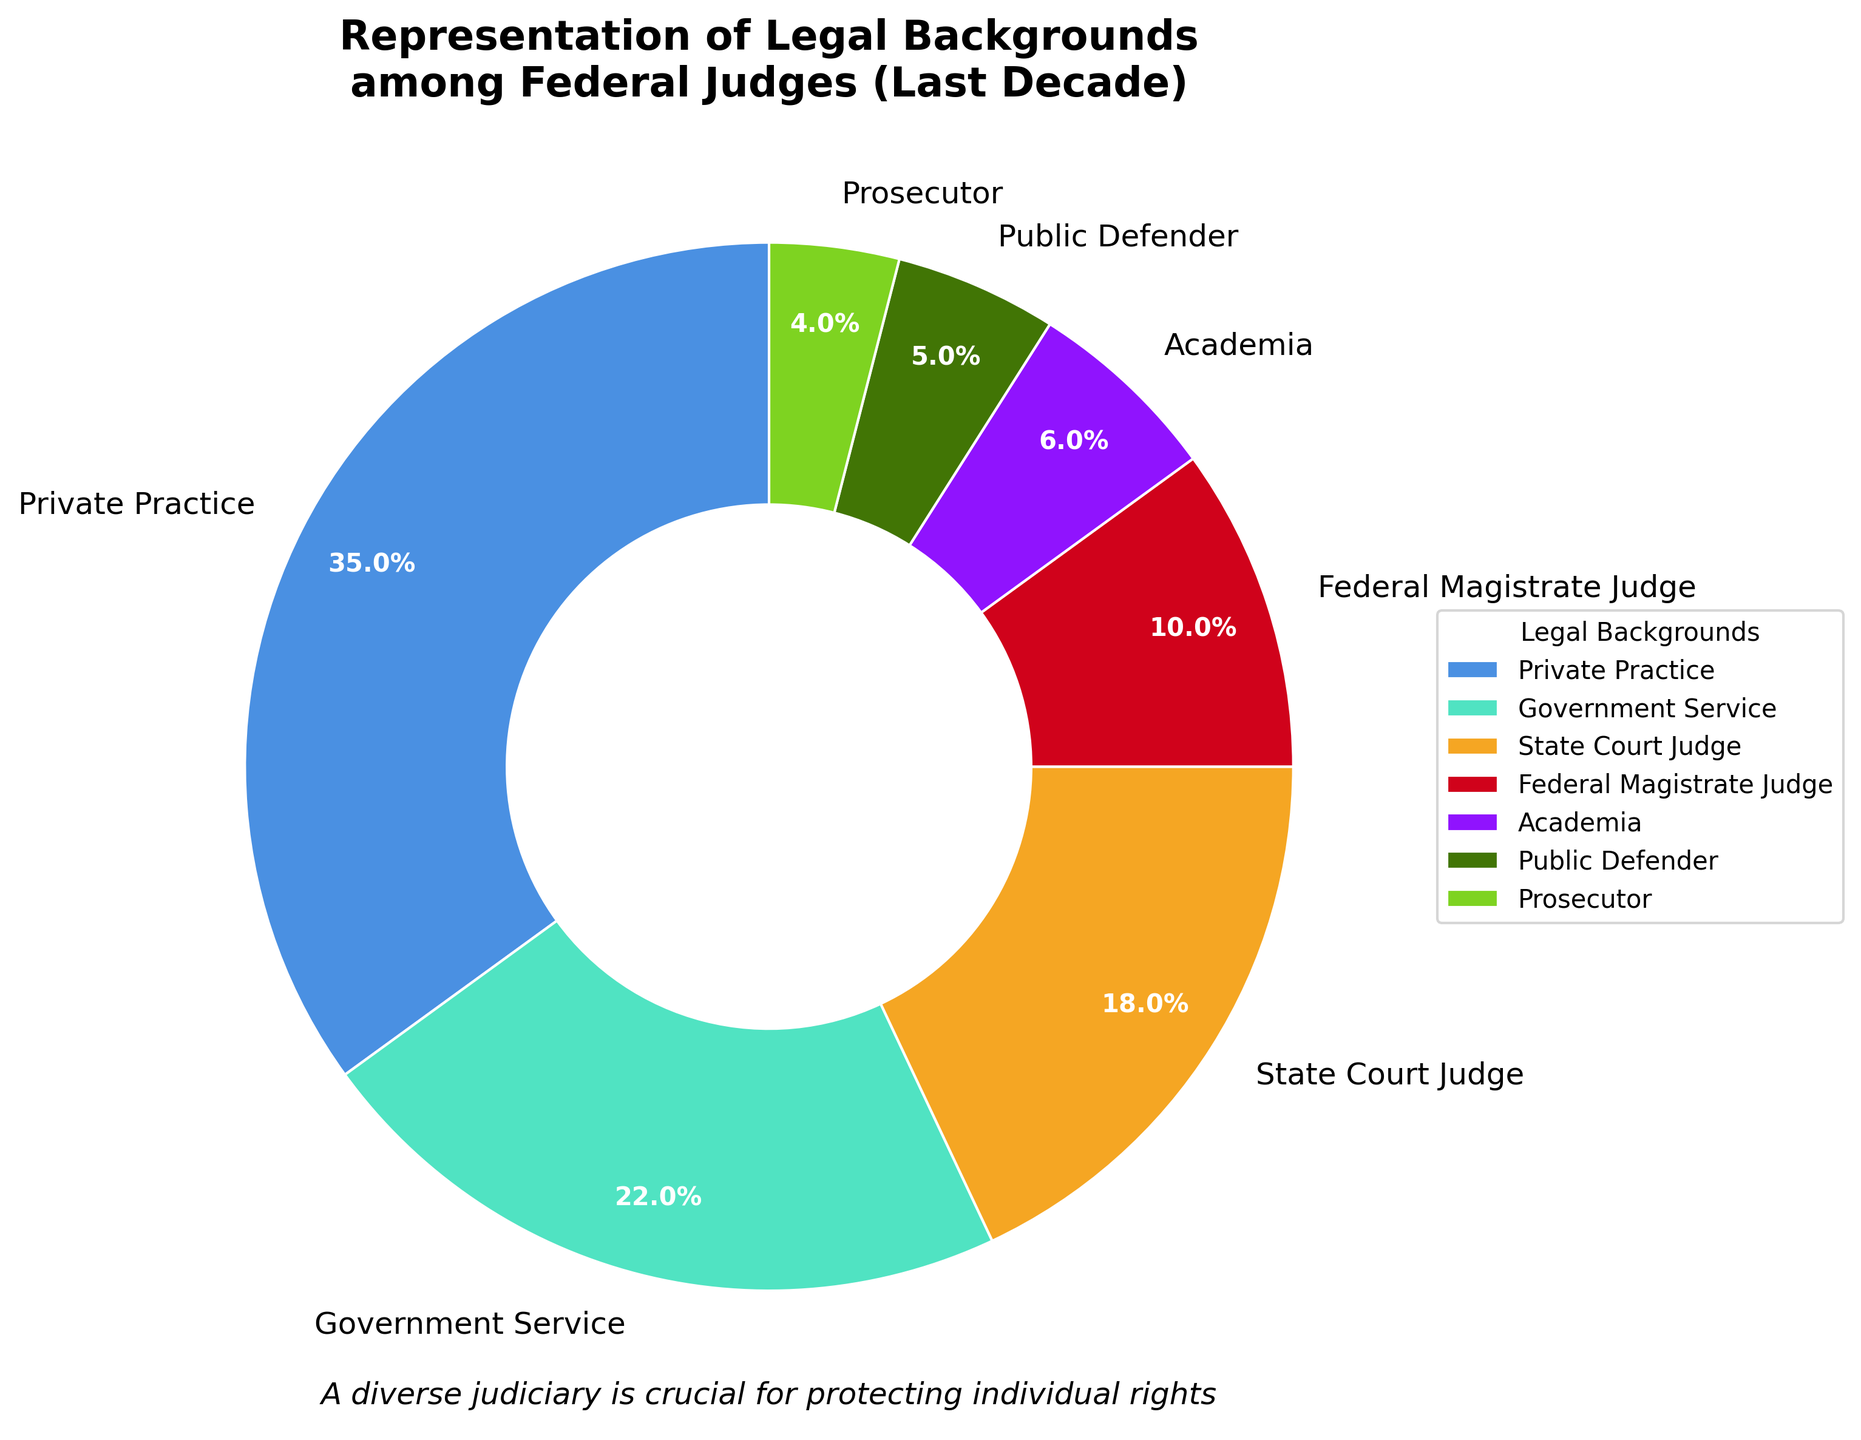What percentage of federal judges come from private practice? According to the pie chart, the segment labeled 'Private Practice' represents the percentage for this legal background.
Answer: 35% Which two categories have the smallest representation among federal judges? To find the two smallest segments, look for the categories with the smallest slices in the pie chart. These are 'Prosecutor' and 'Public Defender'.
Answer: Prosecutor and Public Defender How does the percentage of judges with a background in government service compare to those from academia? The pie chart shows that 'Government Service' represents 22% while 'Academia' represents 6%. 22% is greater than 6%.
Answer: Government Service has a higher percentage than Academia What is the total percentage of judges with backgrounds in either state court or as federal magistrate judges? The percentages for 'State Court Judge' and 'Federal Magistrate Judge' are 18% and 10%, respectively. Adding these together, you get 18% + 10% = 28%.
Answer: 28% Which legal background has the highest representation, and what is its percentage? The pie chart segment with the largest area represents the highest percentage, which is 'Private Practice' at 35%.
Answer: Private Practice, 35% What is the combined percentage of judges who come from either private practice or government service? The percentages for 'Private Practice' and 'Government Service' are 35% and 22%, respectively. Adding these together, you get 35% + 22% = 57%.
Answer: 57% Compare the percentage of judges with a background in public defending to those with a background in prosecuting. From the pie chart, 'Public Defender' is 5% and 'Prosecutor' is 4%. Therefore, 'Public Defender' has a higher percentage than 'Prosecutor'.
Answer: Public Defender has a higher percentage than Prosecutor What is the difference in representation between state court judges and federal magistrate judges? The percentage for 'State Court Judge' is 18% and for 'Federal Magistrate Judge' is 10%. The difference is 18% - 10% = 8%.
Answer: 8% Which background has lower representation: judges from academia or public defenders? From the pie chart, 'Academia' at 6% and 'Public Defender' at 5%. Therefore, 'Public Defender' has a lower representation.
Answer: Public Defender How many legal backgrounds have a representation percentage above 10%? By examining the pie chart, we identify 'Private Practice' (35%), 'Government Service' (22%), and 'State Court Judge' (18%) are all above 10%. This results in 3 categories.
Answer: 3 